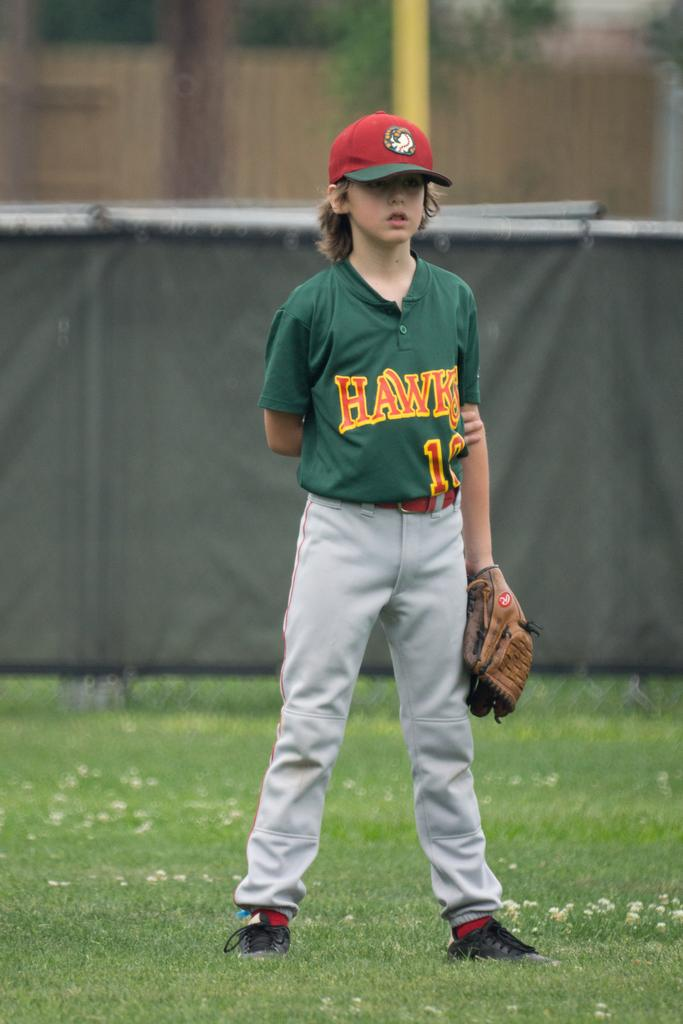<image>
Provide a brief description of the given image. a young boy for the Hawks stands in the field with his glove on his right hand 